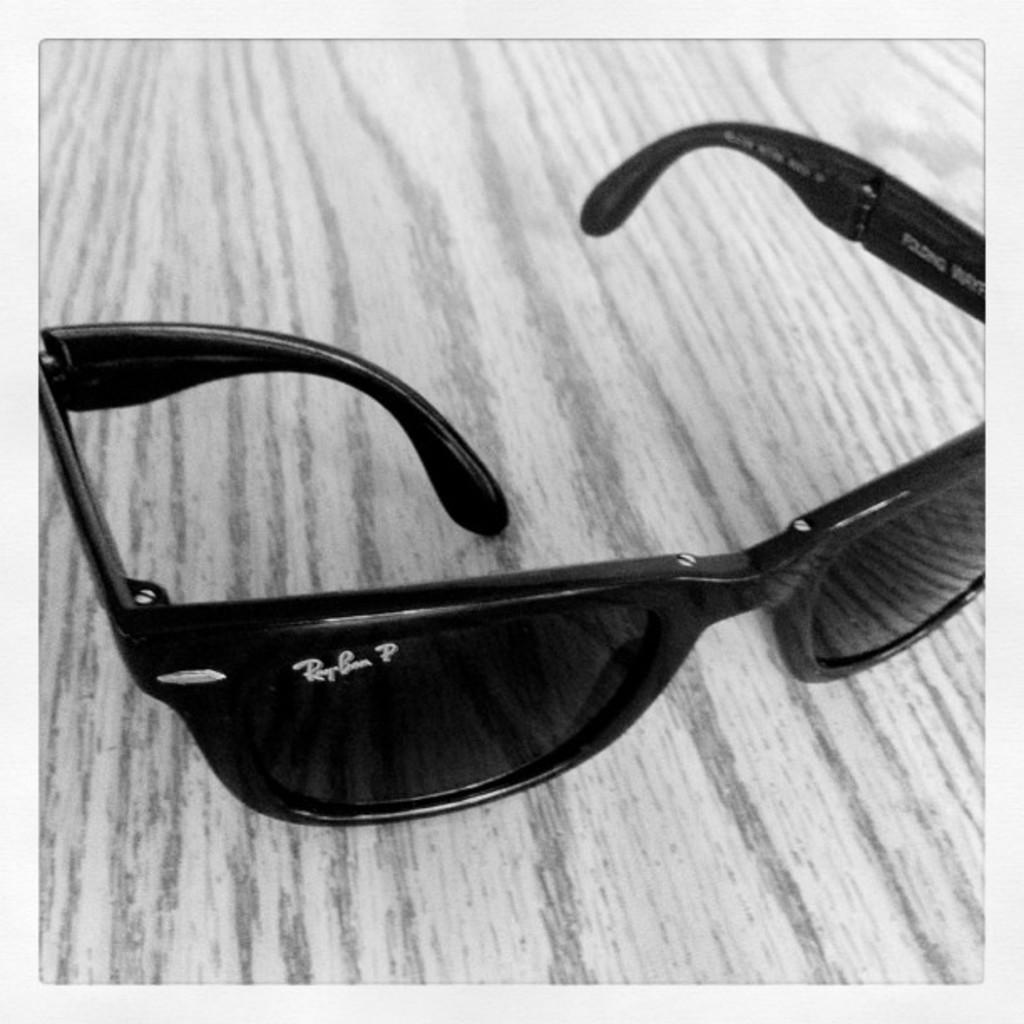What type of protective eyewear is present in the image? There are goggles in the image. Where are the goggles located? on the platform? What type of structure can be seen in the background of the image? There is no structure visible in the background of the image; it only features goggles on a platform. Are there any servants present in the image? There is no mention of servants in the image, as it only features goggles on a platform. 